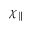Convert formula to latex. <formula><loc_0><loc_0><loc_500><loc_500>\chi _ { \| }</formula> 